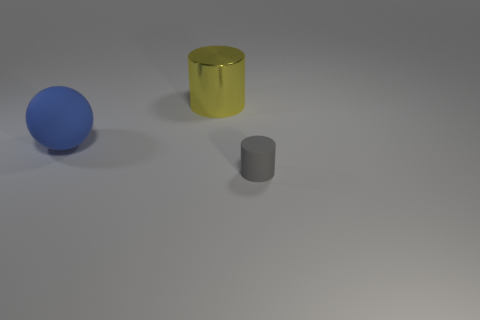Add 3 red cubes. How many objects exist? 6 Subtract all cylinders. How many objects are left? 1 Add 3 small gray matte objects. How many small gray matte objects exist? 4 Subtract 0 yellow blocks. How many objects are left? 3 Subtract all spheres. Subtract all blue matte spheres. How many objects are left? 1 Add 3 tiny things. How many tiny things are left? 4 